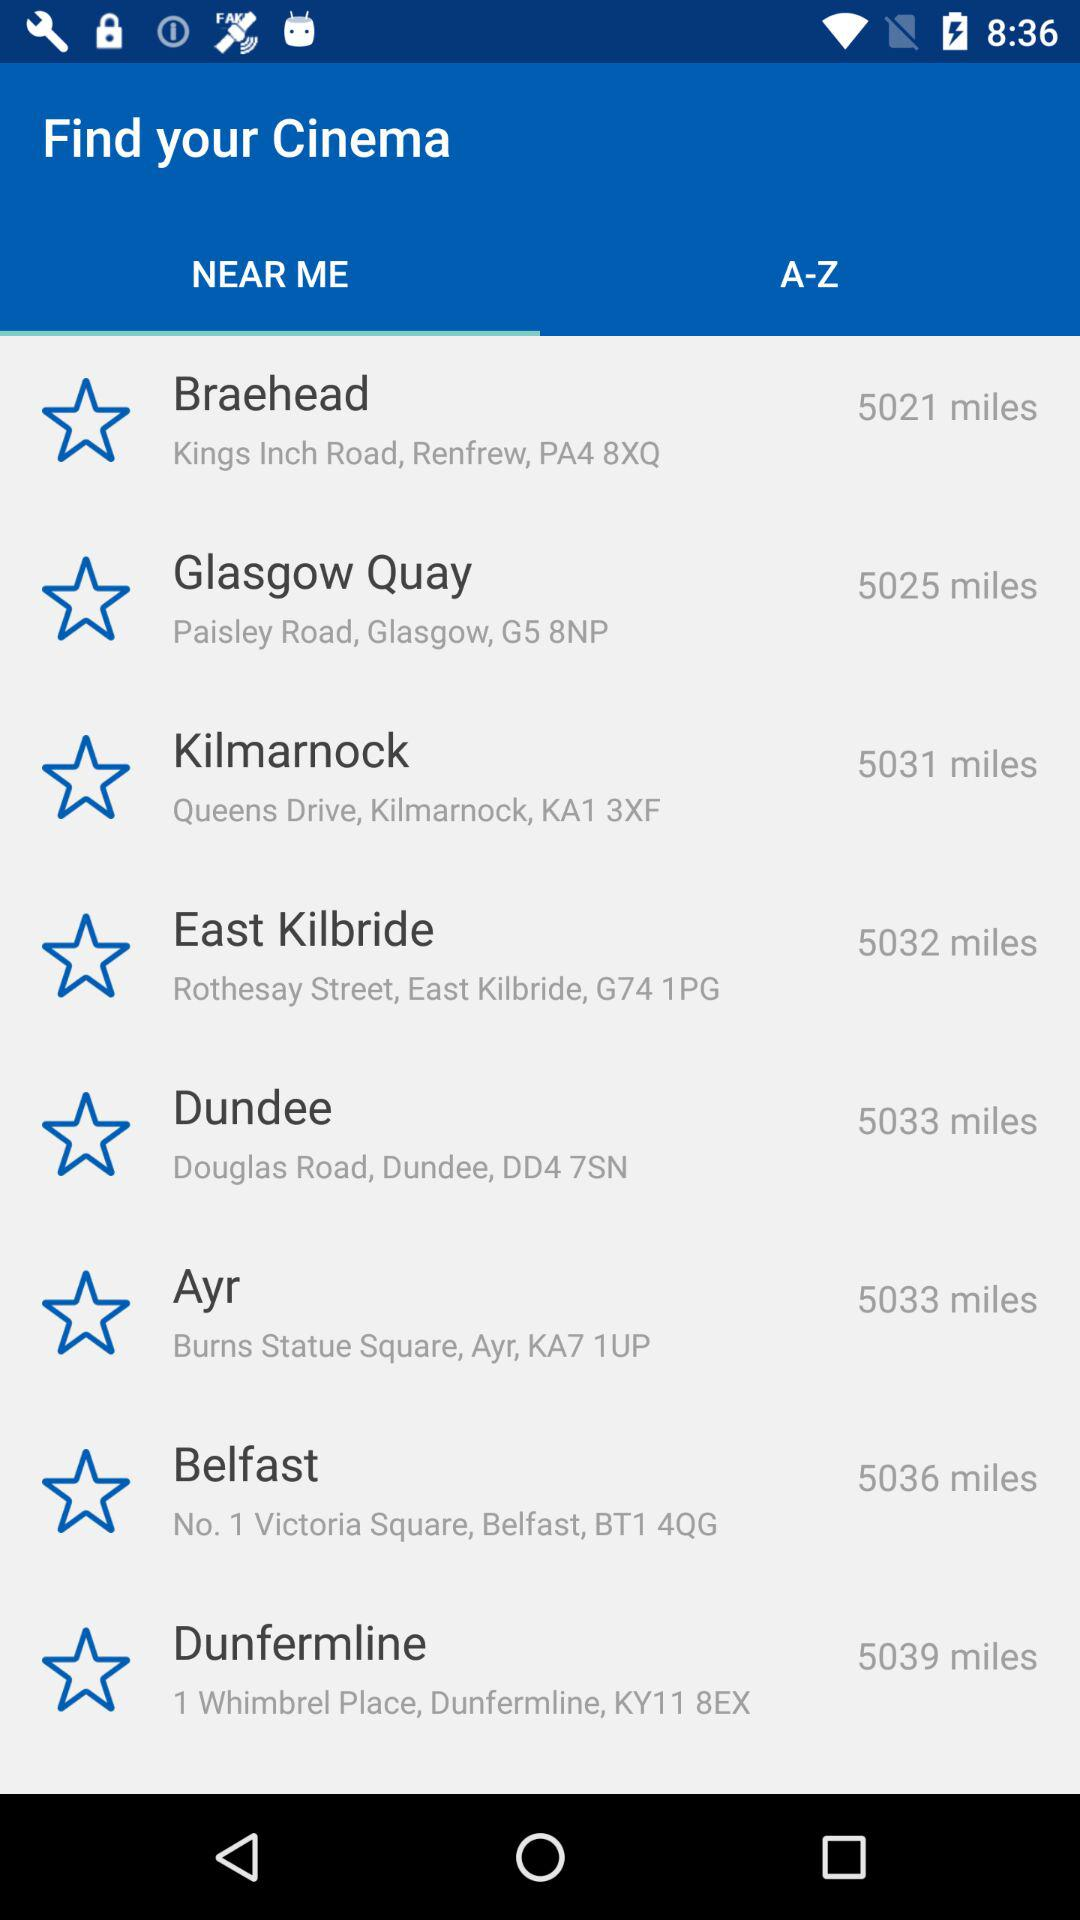What is the address of the Belfast? The address of the Belfast is No. 1 Victoria Square, Belfast, BT1 4QG. 